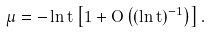Convert formula to latex. <formula><loc_0><loc_0><loc_500><loc_500>\mu = - \ln t \left [ 1 + O \left ( ( \ln t ) ^ { - 1 } \right ) \right ] .</formula> 